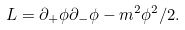Convert formula to latex. <formula><loc_0><loc_0><loc_500><loc_500>L = \partial _ { + } \phi \partial _ { - } \phi - m ^ { 2 } \phi ^ { 2 } / 2 .</formula> 